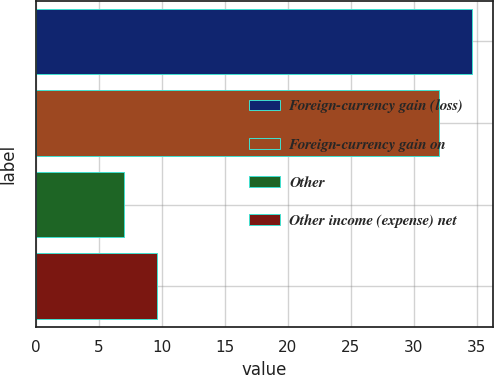Convert chart. <chart><loc_0><loc_0><loc_500><loc_500><bar_chart><fcel>Foreign-currency gain (loss)<fcel>Foreign-currency gain on<fcel>Other<fcel>Other income (expense) net<nl><fcel>34.6<fcel>32<fcel>7<fcel>9.6<nl></chart> 